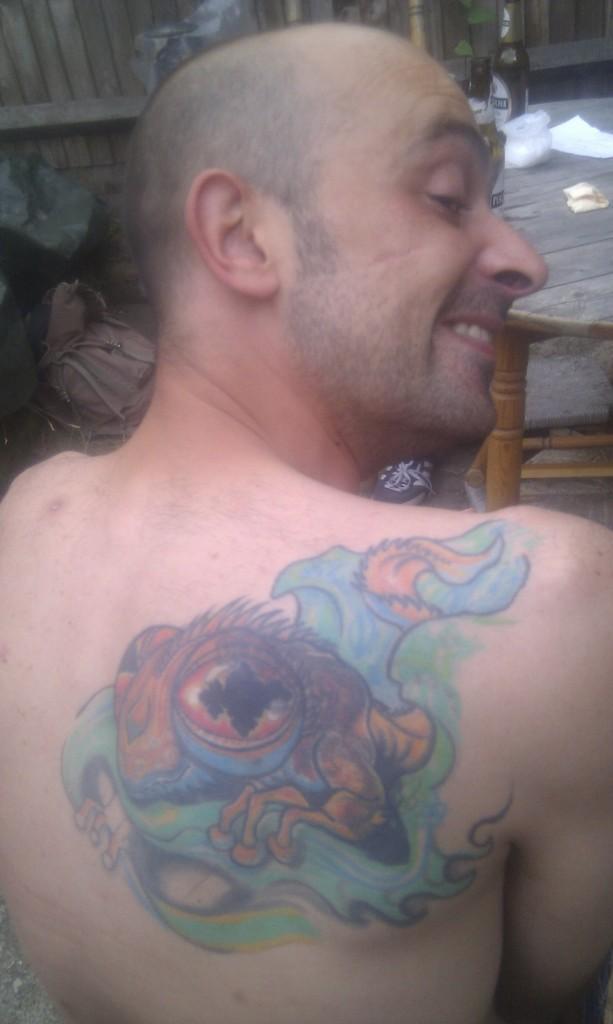In one or two sentences, can you explain what this image depicts? In this picture we can see a man is smiling, there is a tattoo on his body, in the background we can see a table and a chair, there is a cover, a paper and two bottles present on the table, on the left side we can see a bag. 